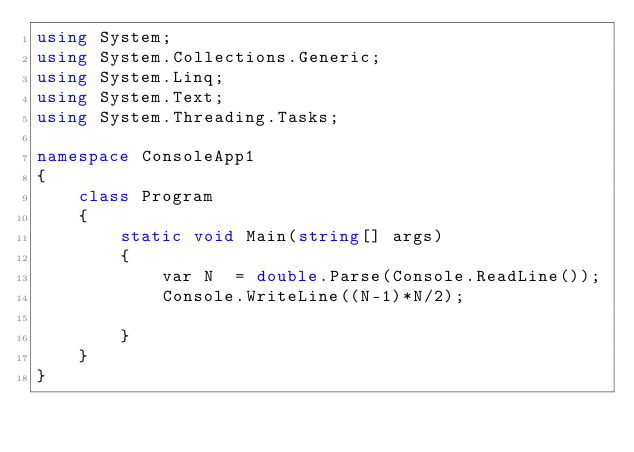<code> <loc_0><loc_0><loc_500><loc_500><_C#_>using System;
using System.Collections.Generic;
using System.Linq;
using System.Text;
using System.Threading.Tasks;

namespace ConsoleApp1
{
    class Program
    {
        static void Main(string[] args)
        {
            var N  = double.Parse(Console.ReadLine());
            Console.WriteLine((N-1)*N/2);

        }
    }
}
</code> 